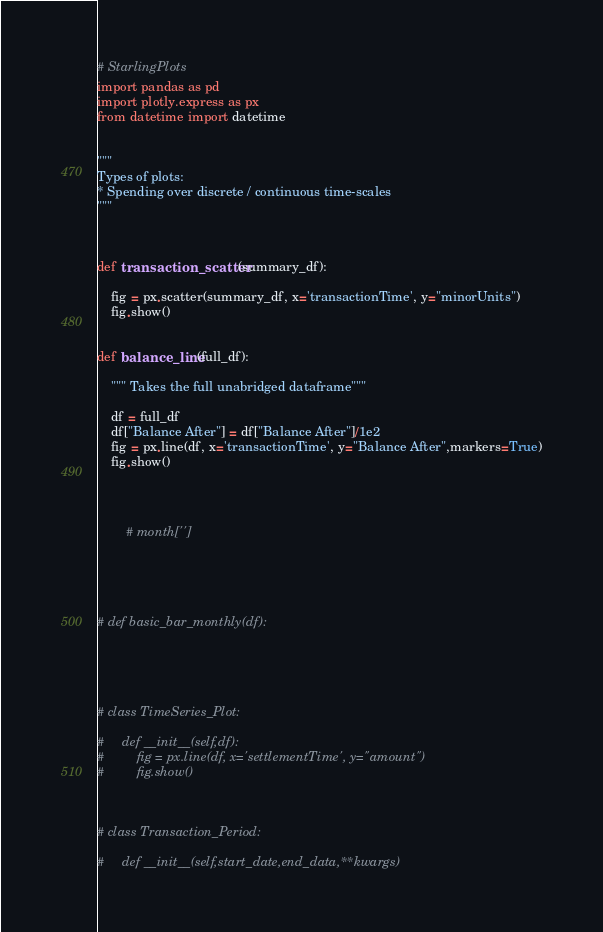<code> <loc_0><loc_0><loc_500><loc_500><_Python_># StarlingPlots
import pandas as pd
import plotly.express as px
from datetime import datetime


"""
Types of plots:
* Spending over discrete / continuous time-scales
"""



def transaction_scatter(summary_df):

    fig = px.scatter(summary_df, x='transactionTime', y="minorUnits")
    fig.show()


def balance_line(full_df):

    """ Takes the full unabridged dataframe"""

    df = full_df
    df["Balance After"] = df["Balance After"]/1e2
    fig = px.line(df, x='transactionTime', y="Balance After",markers=True)
    fig.show()




        # month['']





# def basic_bar_monthly(df):





# class TimeSeries_Plot:

#     def __init__(self,df):
#         fig = px.line(df, x='settlementTime', y="amount")
#         fig.show()



# class Transaction_Period:

#     def __init__(self,start_date,end_data,**kwargs)</code> 